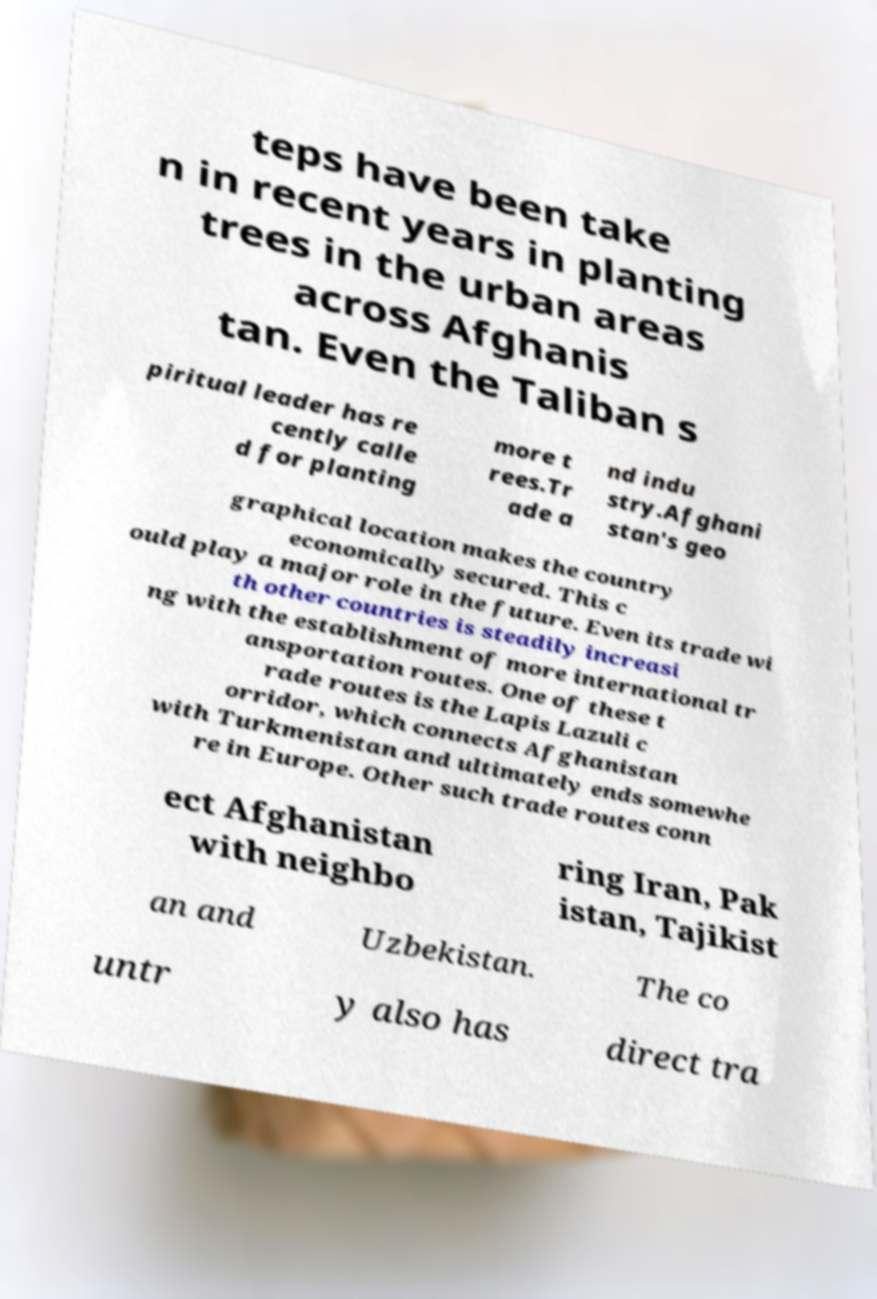Can you read and provide the text displayed in the image?This photo seems to have some interesting text. Can you extract and type it out for me? teps have been take n in recent years in planting trees in the urban areas across Afghanis tan. Even the Taliban s piritual leader has re cently calle d for planting more t rees.Tr ade a nd indu stry.Afghani stan's geo graphical location makes the country economically secured. This c ould play a major role in the future. Even its trade wi th other countries is steadily increasi ng with the establishment of more international tr ansportation routes. One of these t rade routes is the Lapis Lazuli c orridor, which connects Afghanistan with Turkmenistan and ultimately ends somewhe re in Europe. Other such trade routes conn ect Afghanistan with neighbo ring Iran, Pak istan, Tajikist an and Uzbekistan. The co untr y also has direct tra 